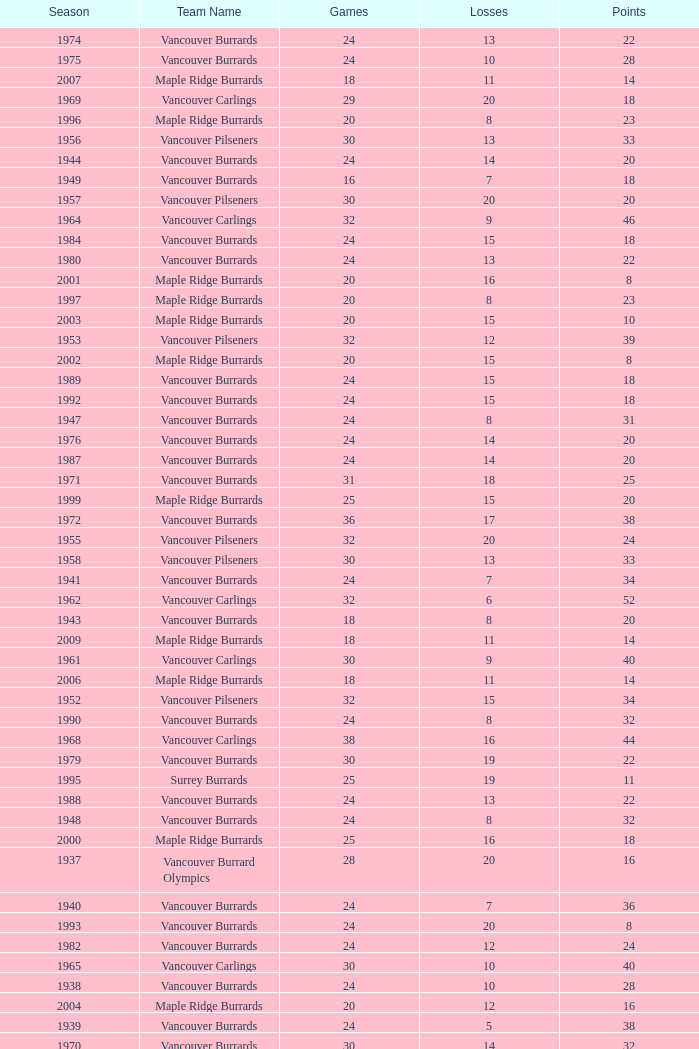What's the lowest number of points with fewer than 8 losses and fewer than 24 games for the vancouver burrards? 18.0. 